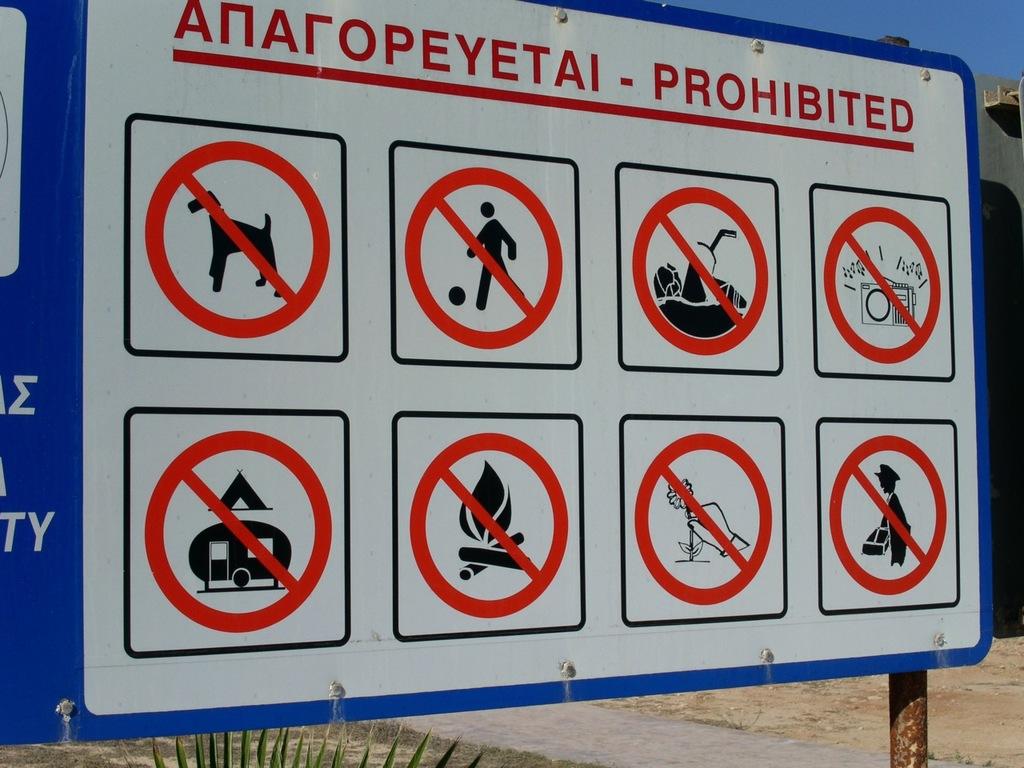Are dogs allowed here?
Your answer should be very brief. No. Can you make a fire here\?
Provide a short and direct response. No. 